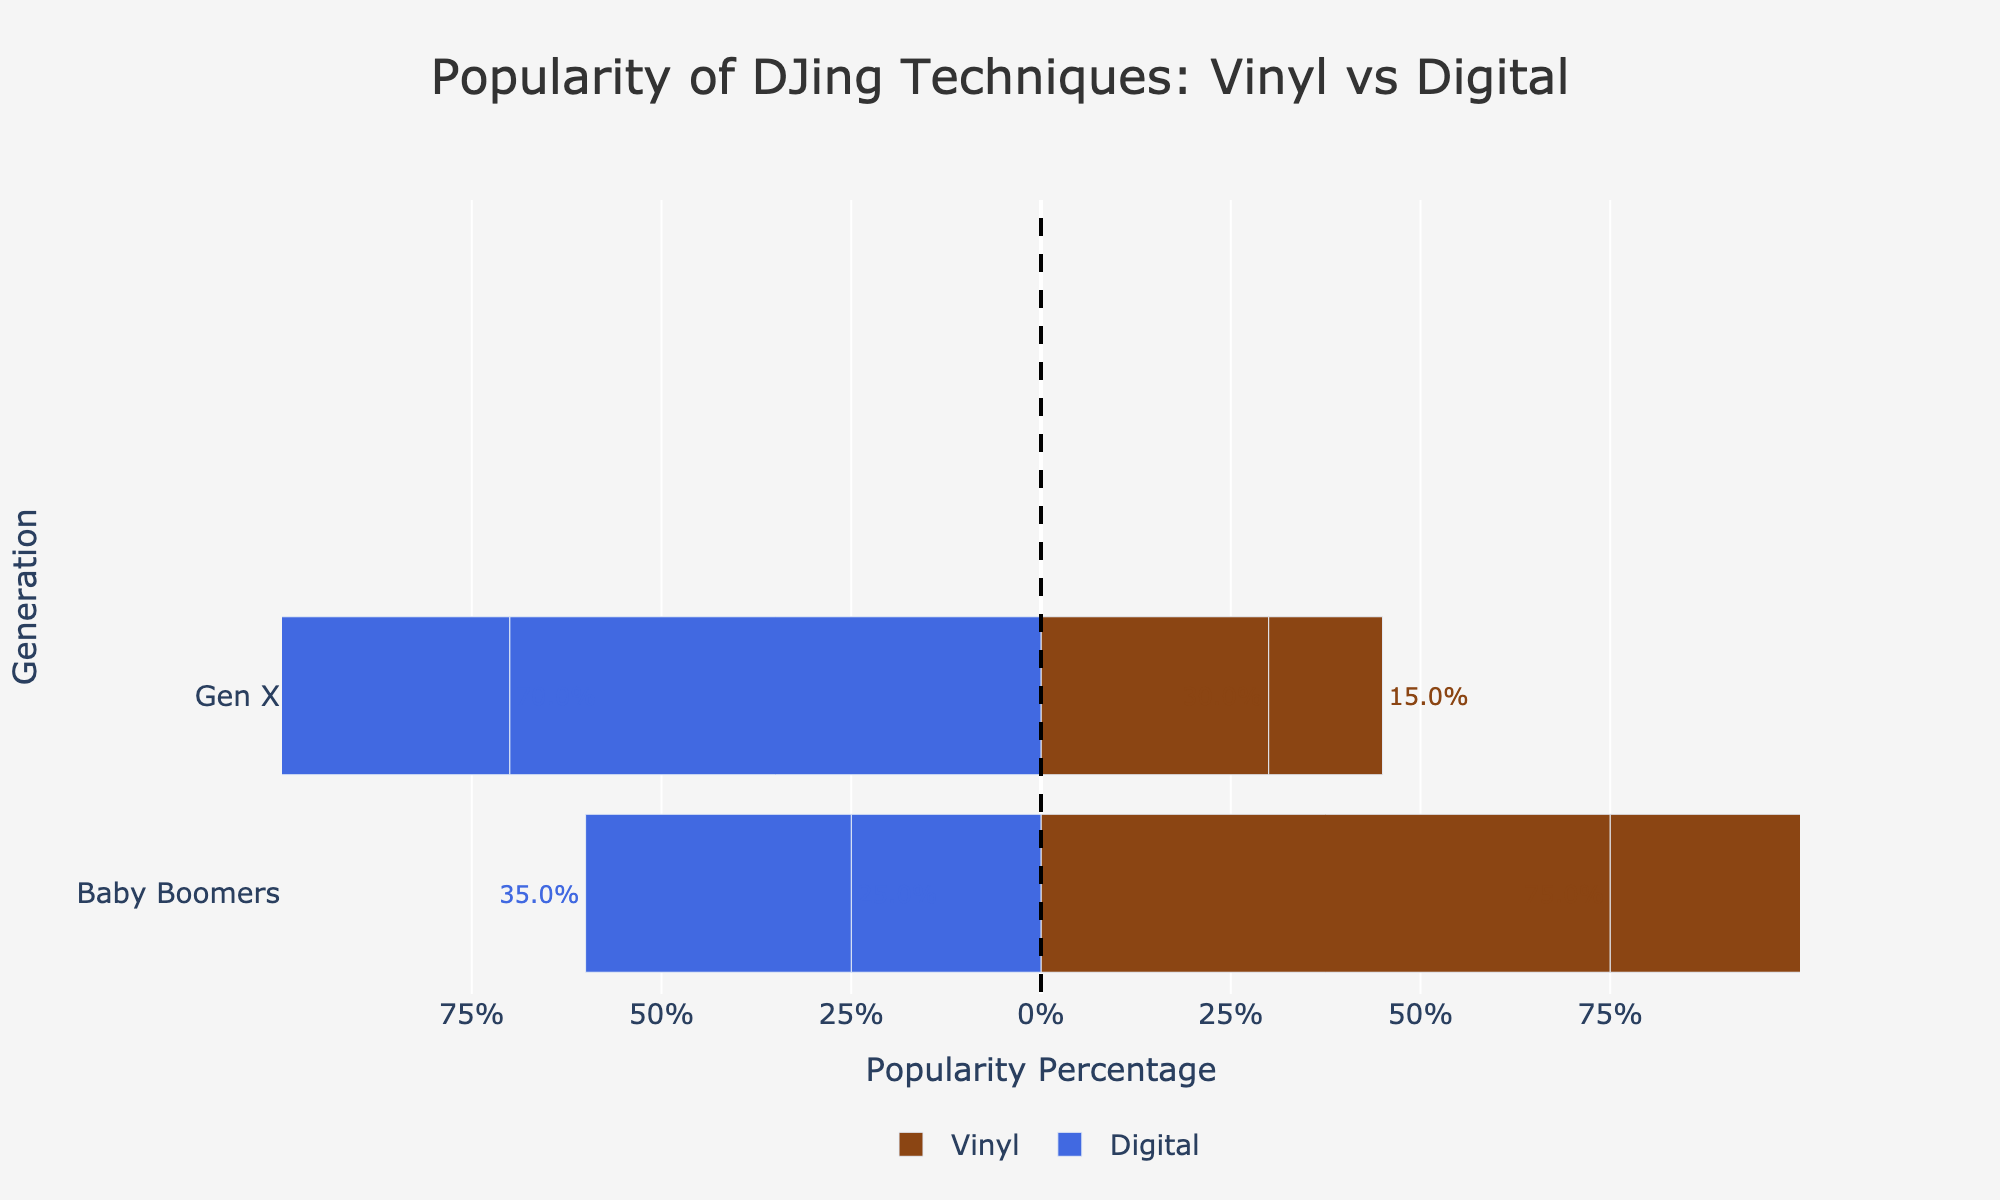Which generation has the highest percentage of popularity for digital DJing? Gen Z has the highest popularity for digital DJing at 85%. This can be seen by looking at the longest blue bar extending to the left.
Answer: Gen Z Which generation shows the most significant preference for vinyl DJing? Baby Boomers have the highest popularity percentage for vinyl DJing at 75%. This can be observed by looking at the longest brown bar extending to the right.
Answer: Baby Boomers What is the difference in digital DJing popularity between Millennials and Gen Z? From the figure, Millennials have a digital DJing popularity of 70%, and Gen Z has 85%. The difference is 85% - 70% = 15%.
Answer: 15% Which generation's preference for vinyl DJing is closest to Gen X's preference for digital DJing in percentage? Gen X's preference for digital DJing is 35%, and Millennials' preference for vinyl DJing is 30%. The difference between these values is the smallest.
Answer: Millennials How much more popular is digital DJing than vinyl DJing among Millennials? Digital DJing is 70% popular among Millennials, while vinyl DJing is 30% popular. The difference is 70% - 30% = 40%.
Answer: 40% Compare the total popularity of vinyl DJing between Baby Boomers and Gen X. Baby Boomers have a 75% popularity for vinyl, and Gen X has 65%. Adding these together gives 75% + 65% = 140%.
Answer: 140% What is the median percentage popularity for digital DJing across the generations? The percentages for digital DJing are 25%, 35%, 70%, and 85%. Ordering these gives 25%, 35%, 70%, 85%. The median is the average of the two middle values: (35% + 70%) / 2 = 52.5%.
Answer: 52.5% Which generation shows an equal combined popularity for vinyl and digital DJing? Gen X has a 65% popularity for vinyl and 35% for digital, adding up to an equal 100%.
Answer: Gen X How does the popularity of digital DJing in Gen X compare visually with vinyl DJing in Millennials? Visually, the blue bar for Gen X’s digital DJing (35%) is shorter and extends less to the left compared to the brown bar for Millennials’ vinyl DJing (30%), which is shorter as it extends to the right.
Answer: Gen X's digital is more What is the average popularity of digital DJing across all generations? The digital DJing percentages are 25%, 35%, 70%, and 85%. Adding these gives 25 + 35 + 70 + 85 = 215. Dividing by the number of generations (4) gives 215 / 4 = 53.75%.
Answer: 53.75% 